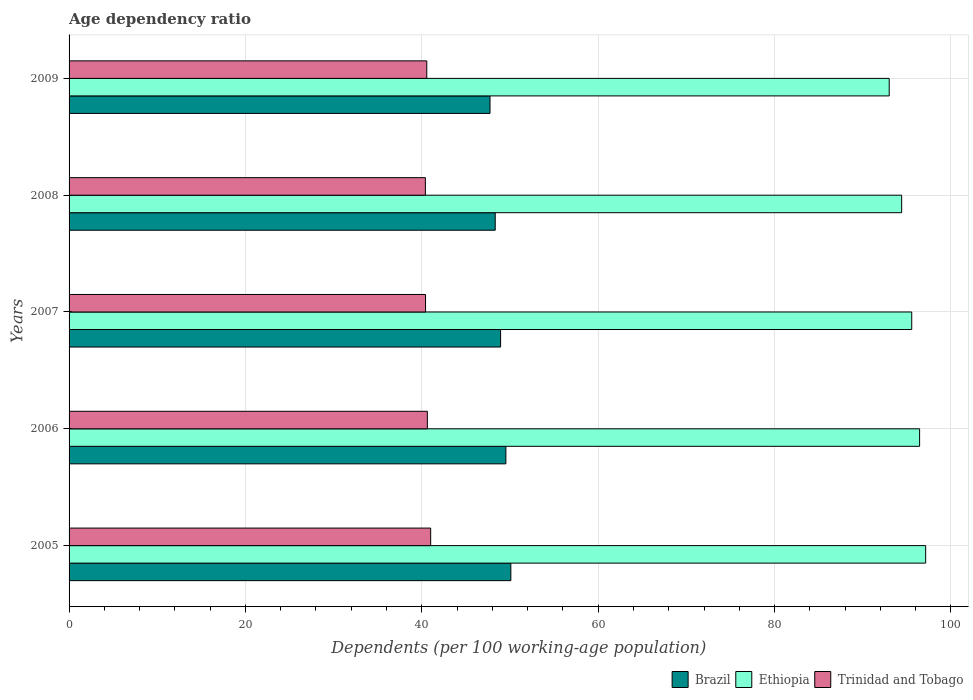How many groups of bars are there?
Offer a terse response. 5. In how many cases, is the number of bars for a given year not equal to the number of legend labels?
Provide a succinct answer. 0. What is the age dependency ratio in in Ethiopia in 2007?
Offer a very short reply. 95.56. Across all years, what is the maximum age dependency ratio in in Brazil?
Provide a succinct answer. 50.1. Across all years, what is the minimum age dependency ratio in in Ethiopia?
Provide a short and direct response. 93. In which year was the age dependency ratio in in Brazil minimum?
Make the answer very short. 2009. What is the total age dependency ratio in in Brazil in the graph?
Provide a short and direct response. 244.62. What is the difference between the age dependency ratio in in Brazil in 2005 and that in 2009?
Offer a very short reply. 2.36. What is the difference between the age dependency ratio in in Brazil in 2009 and the age dependency ratio in in Ethiopia in 2008?
Provide a succinct answer. -46.68. What is the average age dependency ratio in in Ethiopia per year?
Your answer should be compact. 95.31. In the year 2009, what is the difference between the age dependency ratio in in Brazil and age dependency ratio in in Trinidad and Tobago?
Offer a very short reply. 7.17. What is the ratio of the age dependency ratio in in Trinidad and Tobago in 2005 to that in 2008?
Give a very brief answer. 1.01. Is the age dependency ratio in in Brazil in 2008 less than that in 2009?
Make the answer very short. No. Is the difference between the age dependency ratio in in Brazil in 2005 and 2008 greater than the difference between the age dependency ratio in in Trinidad and Tobago in 2005 and 2008?
Make the answer very short. Yes. What is the difference between the highest and the second highest age dependency ratio in in Ethiopia?
Provide a succinct answer. 0.69. What is the difference between the highest and the lowest age dependency ratio in in Trinidad and Tobago?
Offer a terse response. 0.6. Is the sum of the age dependency ratio in in Ethiopia in 2005 and 2006 greater than the maximum age dependency ratio in in Brazil across all years?
Ensure brevity in your answer.  Yes. What does the 1st bar from the top in 2006 represents?
Keep it short and to the point. Trinidad and Tobago. What does the 3rd bar from the bottom in 2006 represents?
Give a very brief answer. Trinidad and Tobago. Is it the case that in every year, the sum of the age dependency ratio in in Trinidad and Tobago and age dependency ratio in in Brazil is greater than the age dependency ratio in in Ethiopia?
Provide a short and direct response. No. How many bars are there?
Keep it short and to the point. 15. Are all the bars in the graph horizontal?
Give a very brief answer. Yes. How many years are there in the graph?
Keep it short and to the point. 5. Are the values on the major ticks of X-axis written in scientific E-notation?
Give a very brief answer. No. Does the graph contain grids?
Provide a short and direct response. Yes. Where does the legend appear in the graph?
Your answer should be compact. Bottom right. What is the title of the graph?
Ensure brevity in your answer.  Age dependency ratio. What is the label or title of the X-axis?
Your response must be concise. Dependents (per 100 working-age population). What is the Dependents (per 100 working-age population) in Brazil in 2005?
Your answer should be compact. 50.1. What is the Dependents (per 100 working-age population) of Ethiopia in 2005?
Offer a terse response. 97.13. What is the Dependents (per 100 working-age population) in Trinidad and Tobago in 2005?
Provide a short and direct response. 41. What is the Dependents (per 100 working-age population) of Brazil in 2006?
Give a very brief answer. 49.53. What is the Dependents (per 100 working-age population) in Ethiopia in 2006?
Offer a terse response. 96.45. What is the Dependents (per 100 working-age population) in Trinidad and Tobago in 2006?
Provide a succinct answer. 40.63. What is the Dependents (per 100 working-age population) of Brazil in 2007?
Offer a terse response. 48.93. What is the Dependents (per 100 working-age population) of Ethiopia in 2007?
Provide a succinct answer. 95.56. What is the Dependents (per 100 working-age population) of Trinidad and Tobago in 2007?
Offer a very short reply. 40.42. What is the Dependents (per 100 working-age population) of Brazil in 2008?
Provide a short and direct response. 48.32. What is the Dependents (per 100 working-age population) of Ethiopia in 2008?
Make the answer very short. 94.41. What is the Dependents (per 100 working-age population) in Trinidad and Tobago in 2008?
Your answer should be very brief. 40.4. What is the Dependents (per 100 working-age population) in Brazil in 2009?
Provide a short and direct response. 47.73. What is the Dependents (per 100 working-age population) of Ethiopia in 2009?
Offer a terse response. 93. What is the Dependents (per 100 working-age population) in Trinidad and Tobago in 2009?
Offer a very short reply. 40.56. Across all years, what is the maximum Dependents (per 100 working-age population) of Brazil?
Your answer should be very brief. 50.1. Across all years, what is the maximum Dependents (per 100 working-age population) in Ethiopia?
Give a very brief answer. 97.13. Across all years, what is the maximum Dependents (per 100 working-age population) in Trinidad and Tobago?
Offer a very short reply. 41. Across all years, what is the minimum Dependents (per 100 working-age population) in Brazil?
Provide a succinct answer. 47.73. Across all years, what is the minimum Dependents (per 100 working-age population) of Ethiopia?
Give a very brief answer. 93. Across all years, what is the minimum Dependents (per 100 working-age population) in Trinidad and Tobago?
Provide a short and direct response. 40.4. What is the total Dependents (per 100 working-age population) of Brazil in the graph?
Ensure brevity in your answer.  244.62. What is the total Dependents (per 100 working-age population) in Ethiopia in the graph?
Give a very brief answer. 476.55. What is the total Dependents (per 100 working-age population) in Trinidad and Tobago in the graph?
Keep it short and to the point. 203.02. What is the difference between the Dependents (per 100 working-age population) in Brazil in 2005 and that in 2006?
Keep it short and to the point. 0.56. What is the difference between the Dependents (per 100 working-age population) of Ethiopia in 2005 and that in 2006?
Your response must be concise. 0.69. What is the difference between the Dependents (per 100 working-age population) of Trinidad and Tobago in 2005 and that in 2006?
Offer a terse response. 0.38. What is the difference between the Dependents (per 100 working-age population) in Brazil in 2005 and that in 2007?
Provide a succinct answer. 1.16. What is the difference between the Dependents (per 100 working-age population) of Ethiopia in 2005 and that in 2007?
Provide a succinct answer. 1.58. What is the difference between the Dependents (per 100 working-age population) of Trinidad and Tobago in 2005 and that in 2007?
Your answer should be very brief. 0.58. What is the difference between the Dependents (per 100 working-age population) in Brazil in 2005 and that in 2008?
Your answer should be compact. 1.77. What is the difference between the Dependents (per 100 working-age population) in Ethiopia in 2005 and that in 2008?
Your response must be concise. 2.72. What is the difference between the Dependents (per 100 working-age population) in Trinidad and Tobago in 2005 and that in 2008?
Ensure brevity in your answer.  0.6. What is the difference between the Dependents (per 100 working-age population) of Brazil in 2005 and that in 2009?
Provide a short and direct response. 2.36. What is the difference between the Dependents (per 100 working-age population) of Ethiopia in 2005 and that in 2009?
Keep it short and to the point. 4.14. What is the difference between the Dependents (per 100 working-age population) in Trinidad and Tobago in 2005 and that in 2009?
Make the answer very short. 0.44. What is the difference between the Dependents (per 100 working-age population) in Brazil in 2006 and that in 2007?
Ensure brevity in your answer.  0.6. What is the difference between the Dependents (per 100 working-age population) of Ethiopia in 2006 and that in 2007?
Provide a succinct answer. 0.89. What is the difference between the Dependents (per 100 working-age population) in Trinidad and Tobago in 2006 and that in 2007?
Your answer should be compact. 0.2. What is the difference between the Dependents (per 100 working-age population) in Brazil in 2006 and that in 2008?
Offer a terse response. 1.21. What is the difference between the Dependents (per 100 working-age population) of Ethiopia in 2006 and that in 2008?
Your response must be concise. 2.04. What is the difference between the Dependents (per 100 working-age population) of Trinidad and Tobago in 2006 and that in 2008?
Your answer should be very brief. 0.22. What is the difference between the Dependents (per 100 working-age population) in Brazil in 2006 and that in 2009?
Ensure brevity in your answer.  1.8. What is the difference between the Dependents (per 100 working-age population) in Ethiopia in 2006 and that in 2009?
Keep it short and to the point. 3.45. What is the difference between the Dependents (per 100 working-age population) in Trinidad and Tobago in 2006 and that in 2009?
Ensure brevity in your answer.  0.07. What is the difference between the Dependents (per 100 working-age population) of Brazil in 2007 and that in 2008?
Your answer should be compact. 0.61. What is the difference between the Dependents (per 100 working-age population) of Ethiopia in 2007 and that in 2008?
Provide a short and direct response. 1.14. What is the difference between the Dependents (per 100 working-age population) of Trinidad and Tobago in 2007 and that in 2008?
Ensure brevity in your answer.  0.02. What is the difference between the Dependents (per 100 working-age population) of Brazil in 2007 and that in 2009?
Give a very brief answer. 1.2. What is the difference between the Dependents (per 100 working-age population) of Ethiopia in 2007 and that in 2009?
Provide a succinct answer. 2.56. What is the difference between the Dependents (per 100 working-age population) in Trinidad and Tobago in 2007 and that in 2009?
Offer a very short reply. -0.14. What is the difference between the Dependents (per 100 working-age population) in Brazil in 2008 and that in 2009?
Your answer should be very brief. 0.59. What is the difference between the Dependents (per 100 working-age population) in Ethiopia in 2008 and that in 2009?
Ensure brevity in your answer.  1.41. What is the difference between the Dependents (per 100 working-age population) of Trinidad and Tobago in 2008 and that in 2009?
Your answer should be very brief. -0.16. What is the difference between the Dependents (per 100 working-age population) of Brazil in 2005 and the Dependents (per 100 working-age population) of Ethiopia in 2006?
Offer a very short reply. -46.35. What is the difference between the Dependents (per 100 working-age population) of Brazil in 2005 and the Dependents (per 100 working-age population) of Trinidad and Tobago in 2006?
Give a very brief answer. 9.47. What is the difference between the Dependents (per 100 working-age population) in Ethiopia in 2005 and the Dependents (per 100 working-age population) in Trinidad and Tobago in 2006?
Keep it short and to the point. 56.51. What is the difference between the Dependents (per 100 working-age population) in Brazil in 2005 and the Dependents (per 100 working-age population) in Ethiopia in 2007?
Make the answer very short. -45.46. What is the difference between the Dependents (per 100 working-age population) of Brazil in 2005 and the Dependents (per 100 working-age population) of Trinidad and Tobago in 2007?
Offer a very short reply. 9.67. What is the difference between the Dependents (per 100 working-age population) in Ethiopia in 2005 and the Dependents (per 100 working-age population) in Trinidad and Tobago in 2007?
Provide a short and direct response. 56.71. What is the difference between the Dependents (per 100 working-age population) in Brazil in 2005 and the Dependents (per 100 working-age population) in Ethiopia in 2008?
Provide a short and direct response. -44.32. What is the difference between the Dependents (per 100 working-age population) in Brazil in 2005 and the Dependents (per 100 working-age population) in Trinidad and Tobago in 2008?
Offer a terse response. 9.69. What is the difference between the Dependents (per 100 working-age population) in Ethiopia in 2005 and the Dependents (per 100 working-age population) in Trinidad and Tobago in 2008?
Offer a terse response. 56.73. What is the difference between the Dependents (per 100 working-age population) of Brazil in 2005 and the Dependents (per 100 working-age population) of Ethiopia in 2009?
Make the answer very short. -42.9. What is the difference between the Dependents (per 100 working-age population) in Brazil in 2005 and the Dependents (per 100 working-age population) in Trinidad and Tobago in 2009?
Your answer should be compact. 9.53. What is the difference between the Dependents (per 100 working-age population) of Ethiopia in 2005 and the Dependents (per 100 working-age population) of Trinidad and Tobago in 2009?
Offer a terse response. 56.57. What is the difference between the Dependents (per 100 working-age population) in Brazil in 2006 and the Dependents (per 100 working-age population) in Ethiopia in 2007?
Your answer should be very brief. -46.02. What is the difference between the Dependents (per 100 working-age population) of Brazil in 2006 and the Dependents (per 100 working-age population) of Trinidad and Tobago in 2007?
Your response must be concise. 9.11. What is the difference between the Dependents (per 100 working-age population) of Ethiopia in 2006 and the Dependents (per 100 working-age population) of Trinidad and Tobago in 2007?
Ensure brevity in your answer.  56.02. What is the difference between the Dependents (per 100 working-age population) in Brazil in 2006 and the Dependents (per 100 working-age population) in Ethiopia in 2008?
Ensure brevity in your answer.  -44.88. What is the difference between the Dependents (per 100 working-age population) in Brazil in 2006 and the Dependents (per 100 working-age population) in Trinidad and Tobago in 2008?
Ensure brevity in your answer.  9.13. What is the difference between the Dependents (per 100 working-age population) of Ethiopia in 2006 and the Dependents (per 100 working-age population) of Trinidad and Tobago in 2008?
Your answer should be very brief. 56.05. What is the difference between the Dependents (per 100 working-age population) in Brazil in 2006 and the Dependents (per 100 working-age population) in Ethiopia in 2009?
Provide a short and direct response. -43.47. What is the difference between the Dependents (per 100 working-age population) of Brazil in 2006 and the Dependents (per 100 working-age population) of Trinidad and Tobago in 2009?
Your response must be concise. 8.97. What is the difference between the Dependents (per 100 working-age population) of Ethiopia in 2006 and the Dependents (per 100 working-age population) of Trinidad and Tobago in 2009?
Your answer should be very brief. 55.89. What is the difference between the Dependents (per 100 working-age population) in Brazil in 2007 and the Dependents (per 100 working-age population) in Ethiopia in 2008?
Make the answer very short. -45.48. What is the difference between the Dependents (per 100 working-age population) of Brazil in 2007 and the Dependents (per 100 working-age population) of Trinidad and Tobago in 2008?
Keep it short and to the point. 8.53. What is the difference between the Dependents (per 100 working-age population) of Ethiopia in 2007 and the Dependents (per 100 working-age population) of Trinidad and Tobago in 2008?
Ensure brevity in your answer.  55.15. What is the difference between the Dependents (per 100 working-age population) in Brazil in 2007 and the Dependents (per 100 working-age population) in Ethiopia in 2009?
Keep it short and to the point. -44.07. What is the difference between the Dependents (per 100 working-age population) of Brazil in 2007 and the Dependents (per 100 working-age population) of Trinidad and Tobago in 2009?
Make the answer very short. 8.37. What is the difference between the Dependents (per 100 working-age population) of Ethiopia in 2007 and the Dependents (per 100 working-age population) of Trinidad and Tobago in 2009?
Provide a short and direct response. 54.99. What is the difference between the Dependents (per 100 working-age population) of Brazil in 2008 and the Dependents (per 100 working-age population) of Ethiopia in 2009?
Your answer should be compact. -44.68. What is the difference between the Dependents (per 100 working-age population) in Brazil in 2008 and the Dependents (per 100 working-age population) in Trinidad and Tobago in 2009?
Keep it short and to the point. 7.76. What is the difference between the Dependents (per 100 working-age population) in Ethiopia in 2008 and the Dependents (per 100 working-age population) in Trinidad and Tobago in 2009?
Provide a short and direct response. 53.85. What is the average Dependents (per 100 working-age population) in Brazil per year?
Provide a short and direct response. 48.92. What is the average Dependents (per 100 working-age population) in Ethiopia per year?
Your response must be concise. 95.31. What is the average Dependents (per 100 working-age population) in Trinidad and Tobago per year?
Your answer should be very brief. 40.6. In the year 2005, what is the difference between the Dependents (per 100 working-age population) of Brazil and Dependents (per 100 working-age population) of Ethiopia?
Give a very brief answer. -47.04. In the year 2005, what is the difference between the Dependents (per 100 working-age population) of Brazil and Dependents (per 100 working-age population) of Trinidad and Tobago?
Ensure brevity in your answer.  9.09. In the year 2005, what is the difference between the Dependents (per 100 working-age population) of Ethiopia and Dependents (per 100 working-age population) of Trinidad and Tobago?
Offer a very short reply. 56.13. In the year 2006, what is the difference between the Dependents (per 100 working-age population) of Brazil and Dependents (per 100 working-age population) of Ethiopia?
Offer a very short reply. -46.92. In the year 2006, what is the difference between the Dependents (per 100 working-age population) of Brazil and Dependents (per 100 working-age population) of Trinidad and Tobago?
Make the answer very short. 8.9. In the year 2006, what is the difference between the Dependents (per 100 working-age population) of Ethiopia and Dependents (per 100 working-age population) of Trinidad and Tobago?
Your response must be concise. 55.82. In the year 2007, what is the difference between the Dependents (per 100 working-age population) of Brazil and Dependents (per 100 working-age population) of Ethiopia?
Offer a terse response. -46.62. In the year 2007, what is the difference between the Dependents (per 100 working-age population) in Brazil and Dependents (per 100 working-age population) in Trinidad and Tobago?
Provide a succinct answer. 8.51. In the year 2007, what is the difference between the Dependents (per 100 working-age population) in Ethiopia and Dependents (per 100 working-age population) in Trinidad and Tobago?
Offer a very short reply. 55.13. In the year 2008, what is the difference between the Dependents (per 100 working-age population) of Brazil and Dependents (per 100 working-age population) of Ethiopia?
Offer a very short reply. -46.09. In the year 2008, what is the difference between the Dependents (per 100 working-age population) of Brazil and Dependents (per 100 working-age population) of Trinidad and Tobago?
Provide a short and direct response. 7.92. In the year 2008, what is the difference between the Dependents (per 100 working-age population) of Ethiopia and Dependents (per 100 working-age population) of Trinidad and Tobago?
Your answer should be compact. 54.01. In the year 2009, what is the difference between the Dependents (per 100 working-age population) in Brazil and Dependents (per 100 working-age population) in Ethiopia?
Keep it short and to the point. -45.27. In the year 2009, what is the difference between the Dependents (per 100 working-age population) in Brazil and Dependents (per 100 working-age population) in Trinidad and Tobago?
Provide a short and direct response. 7.17. In the year 2009, what is the difference between the Dependents (per 100 working-age population) of Ethiopia and Dependents (per 100 working-age population) of Trinidad and Tobago?
Offer a very short reply. 52.44. What is the ratio of the Dependents (per 100 working-age population) of Brazil in 2005 to that in 2006?
Your answer should be compact. 1.01. What is the ratio of the Dependents (per 100 working-age population) of Ethiopia in 2005 to that in 2006?
Your answer should be very brief. 1.01. What is the ratio of the Dependents (per 100 working-age population) in Trinidad and Tobago in 2005 to that in 2006?
Make the answer very short. 1.01. What is the ratio of the Dependents (per 100 working-age population) of Brazil in 2005 to that in 2007?
Keep it short and to the point. 1.02. What is the ratio of the Dependents (per 100 working-age population) of Ethiopia in 2005 to that in 2007?
Your answer should be compact. 1.02. What is the ratio of the Dependents (per 100 working-age population) of Trinidad and Tobago in 2005 to that in 2007?
Offer a terse response. 1.01. What is the ratio of the Dependents (per 100 working-age population) in Brazil in 2005 to that in 2008?
Offer a very short reply. 1.04. What is the ratio of the Dependents (per 100 working-age population) in Ethiopia in 2005 to that in 2008?
Give a very brief answer. 1.03. What is the ratio of the Dependents (per 100 working-age population) of Trinidad and Tobago in 2005 to that in 2008?
Your answer should be very brief. 1.01. What is the ratio of the Dependents (per 100 working-age population) of Brazil in 2005 to that in 2009?
Keep it short and to the point. 1.05. What is the ratio of the Dependents (per 100 working-age population) in Ethiopia in 2005 to that in 2009?
Give a very brief answer. 1.04. What is the ratio of the Dependents (per 100 working-age population) of Trinidad and Tobago in 2005 to that in 2009?
Provide a short and direct response. 1.01. What is the ratio of the Dependents (per 100 working-age population) in Brazil in 2006 to that in 2007?
Provide a succinct answer. 1.01. What is the ratio of the Dependents (per 100 working-age population) in Ethiopia in 2006 to that in 2007?
Offer a terse response. 1.01. What is the ratio of the Dependents (per 100 working-age population) in Brazil in 2006 to that in 2008?
Give a very brief answer. 1.02. What is the ratio of the Dependents (per 100 working-age population) of Ethiopia in 2006 to that in 2008?
Give a very brief answer. 1.02. What is the ratio of the Dependents (per 100 working-age population) of Trinidad and Tobago in 2006 to that in 2008?
Provide a short and direct response. 1.01. What is the ratio of the Dependents (per 100 working-age population) in Brazil in 2006 to that in 2009?
Your answer should be very brief. 1.04. What is the ratio of the Dependents (per 100 working-age population) of Ethiopia in 2006 to that in 2009?
Offer a terse response. 1.04. What is the ratio of the Dependents (per 100 working-age population) in Brazil in 2007 to that in 2008?
Give a very brief answer. 1.01. What is the ratio of the Dependents (per 100 working-age population) in Ethiopia in 2007 to that in 2008?
Your answer should be very brief. 1.01. What is the ratio of the Dependents (per 100 working-age population) of Brazil in 2007 to that in 2009?
Give a very brief answer. 1.03. What is the ratio of the Dependents (per 100 working-age population) of Ethiopia in 2007 to that in 2009?
Your response must be concise. 1.03. What is the ratio of the Dependents (per 100 working-age population) in Brazil in 2008 to that in 2009?
Make the answer very short. 1.01. What is the ratio of the Dependents (per 100 working-age population) in Ethiopia in 2008 to that in 2009?
Your response must be concise. 1.02. What is the ratio of the Dependents (per 100 working-age population) of Trinidad and Tobago in 2008 to that in 2009?
Your answer should be very brief. 1. What is the difference between the highest and the second highest Dependents (per 100 working-age population) in Brazil?
Your answer should be very brief. 0.56. What is the difference between the highest and the second highest Dependents (per 100 working-age population) in Ethiopia?
Offer a terse response. 0.69. What is the difference between the highest and the second highest Dependents (per 100 working-age population) of Trinidad and Tobago?
Your answer should be very brief. 0.38. What is the difference between the highest and the lowest Dependents (per 100 working-age population) of Brazil?
Give a very brief answer. 2.36. What is the difference between the highest and the lowest Dependents (per 100 working-age population) of Ethiopia?
Offer a terse response. 4.14. What is the difference between the highest and the lowest Dependents (per 100 working-age population) of Trinidad and Tobago?
Ensure brevity in your answer.  0.6. 